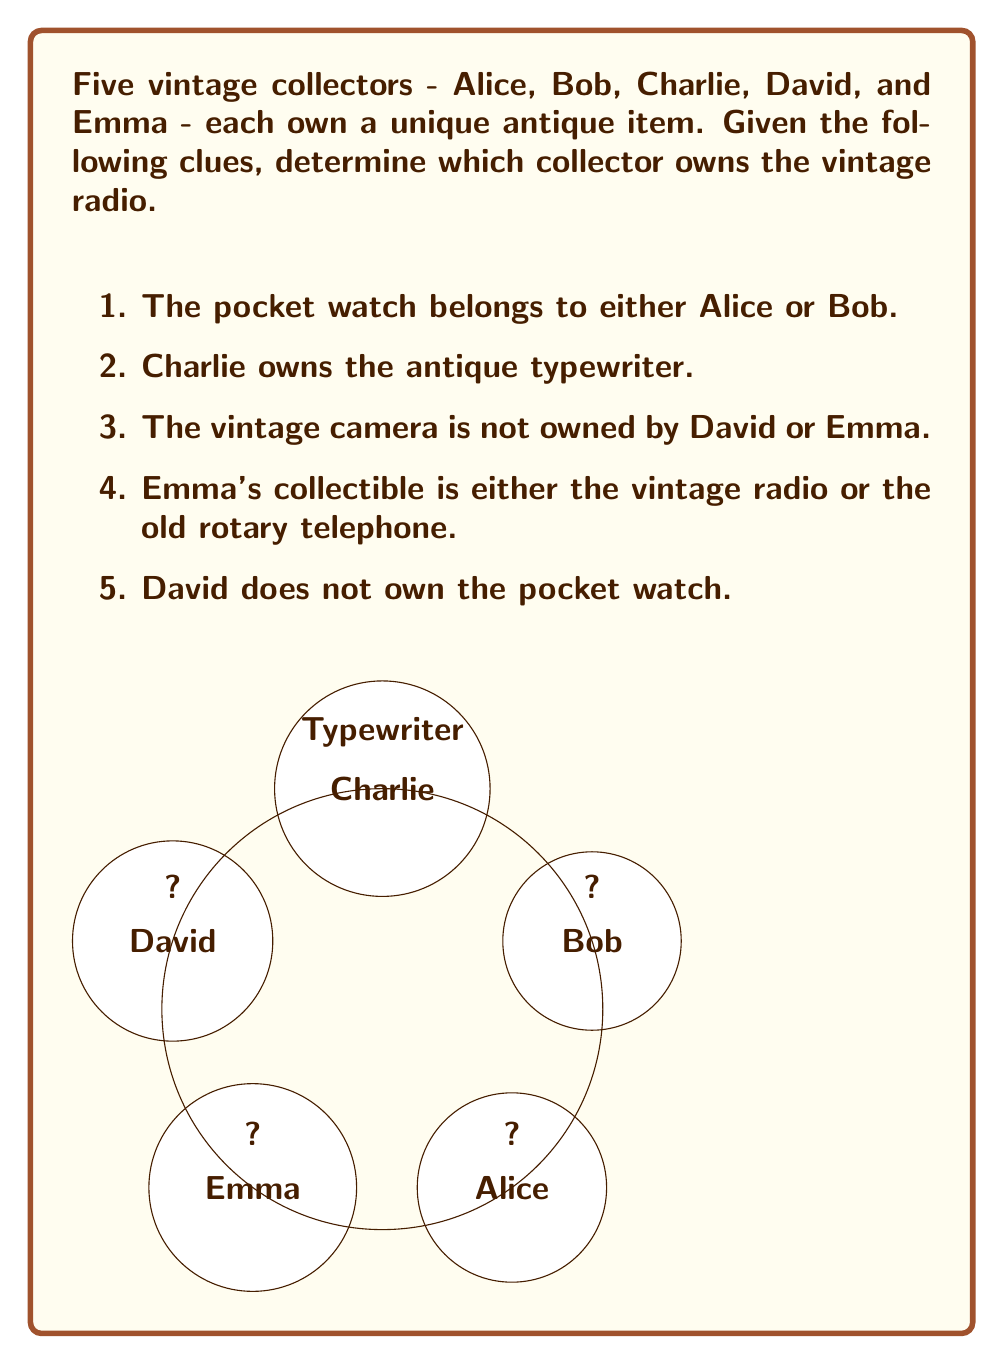Help me with this question. Let's solve this step-by-step using logical deduction:

1. We know Charlie owns the typewriter, so we can eliminate that item and person from consideration for the other items.

2. Emma owns either the radio or the rotary telephone. Let's consider both cases:

   Case A: If Emma owns the radio, we're done.
   Case B: If Emma owns the telephone, someone else must own the radio.

3. The camera is not owned by David or Emma. Since Charlie owns the typewriter, the camera must belong to either Alice or Bob.

4. The pocket watch belongs to either Alice or Bob, and we know David doesn't own it.

5. Let's consider Case B (Emma owns the telephone):
   - If Alice owns the pocket watch, Bob must have the camera.
   - If Bob owns the pocket watch, Alice must have the camera.
   - In either scenario, this leaves David with the radio.

6. However, if David owned the radio, that would contradict the possibility of Case A (Emma owning the radio).

7. Therefore, Case A must be true: Emma owns the vintage radio.

This logical deduction process eliminates all other possibilities and leads us to the conclusion that Emma is the owner of the vintage radio.
Answer: Emma 